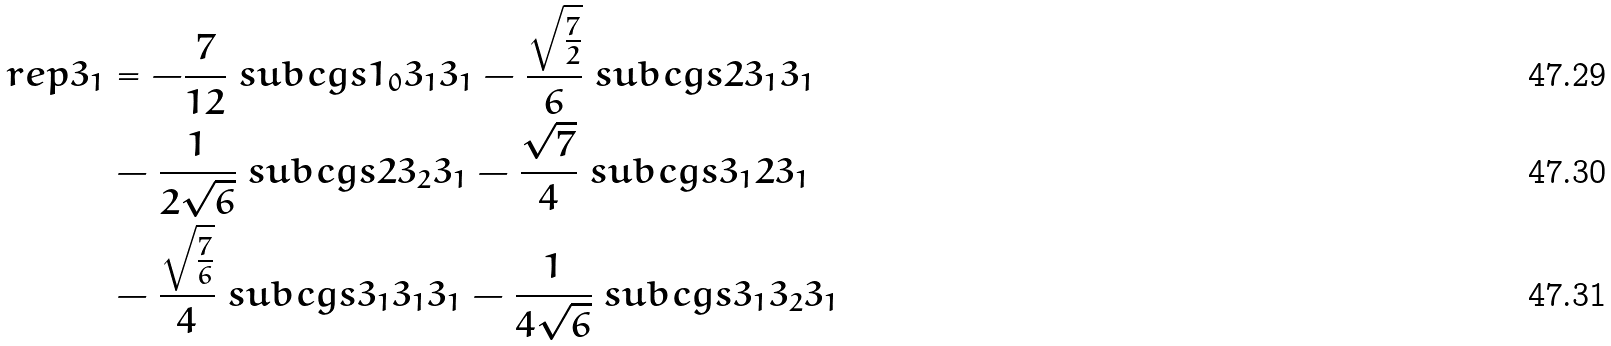<formula> <loc_0><loc_0><loc_500><loc_500>\ r e p { 3 } _ { 1 } & = - \frac { 7 } { 1 2 } \ s u b c g s { 1 _ { 0 } } { 3 _ { 1 } } { 3 _ { 1 } } - \frac { \sqrt { \frac { 7 } { 2 } } } { 6 } \ s u b c g s { 2 } { 3 _ { 1 } } { 3 _ { 1 } } \\ & - \frac { 1 } { 2 \sqrt { 6 } } \ s u b c g s { 2 } { 3 _ { 2 } } { 3 _ { 1 } } - \frac { \sqrt { 7 } } { 4 } \ s u b c g s { 3 _ { 1 } } { 2 } { 3 _ { 1 } } \\ & - \frac { \sqrt { \frac { 7 } { 6 } } } { 4 } \ s u b c g s { 3 _ { 1 } } { 3 _ { 1 } } { 3 _ { 1 } } - \frac { 1 } { 4 \sqrt { 6 } } \ s u b c g s { 3 _ { 1 } } { 3 _ { 2 } } { 3 _ { 1 } }</formula> 